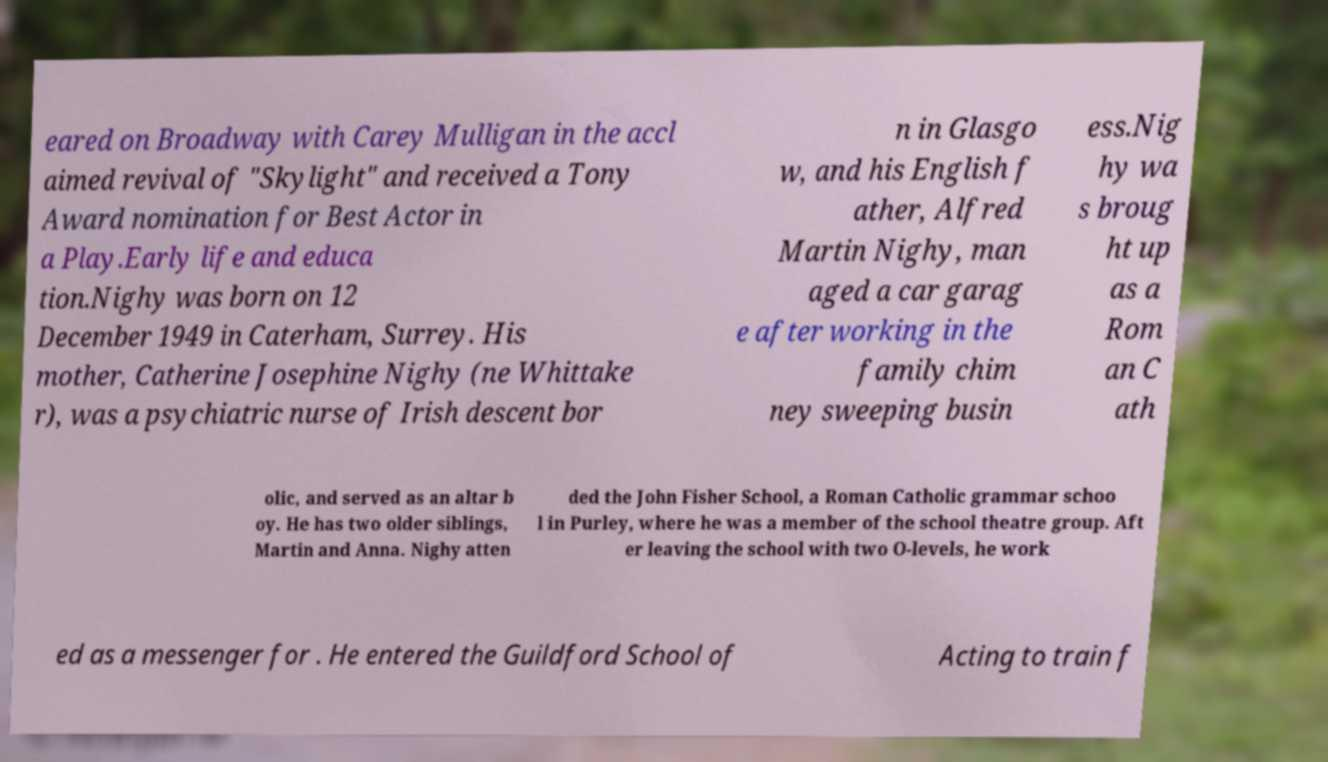What messages or text are displayed in this image? I need them in a readable, typed format. eared on Broadway with Carey Mulligan in the accl aimed revival of "Skylight" and received a Tony Award nomination for Best Actor in a Play.Early life and educa tion.Nighy was born on 12 December 1949 in Caterham, Surrey. His mother, Catherine Josephine Nighy (ne Whittake r), was a psychiatric nurse of Irish descent bor n in Glasgo w, and his English f ather, Alfred Martin Nighy, man aged a car garag e after working in the family chim ney sweeping busin ess.Nig hy wa s broug ht up as a Rom an C ath olic, and served as an altar b oy. He has two older siblings, Martin and Anna. Nighy atten ded the John Fisher School, a Roman Catholic grammar schoo l in Purley, where he was a member of the school theatre group. Aft er leaving the school with two O-levels, he work ed as a messenger for . He entered the Guildford School of Acting to train f 